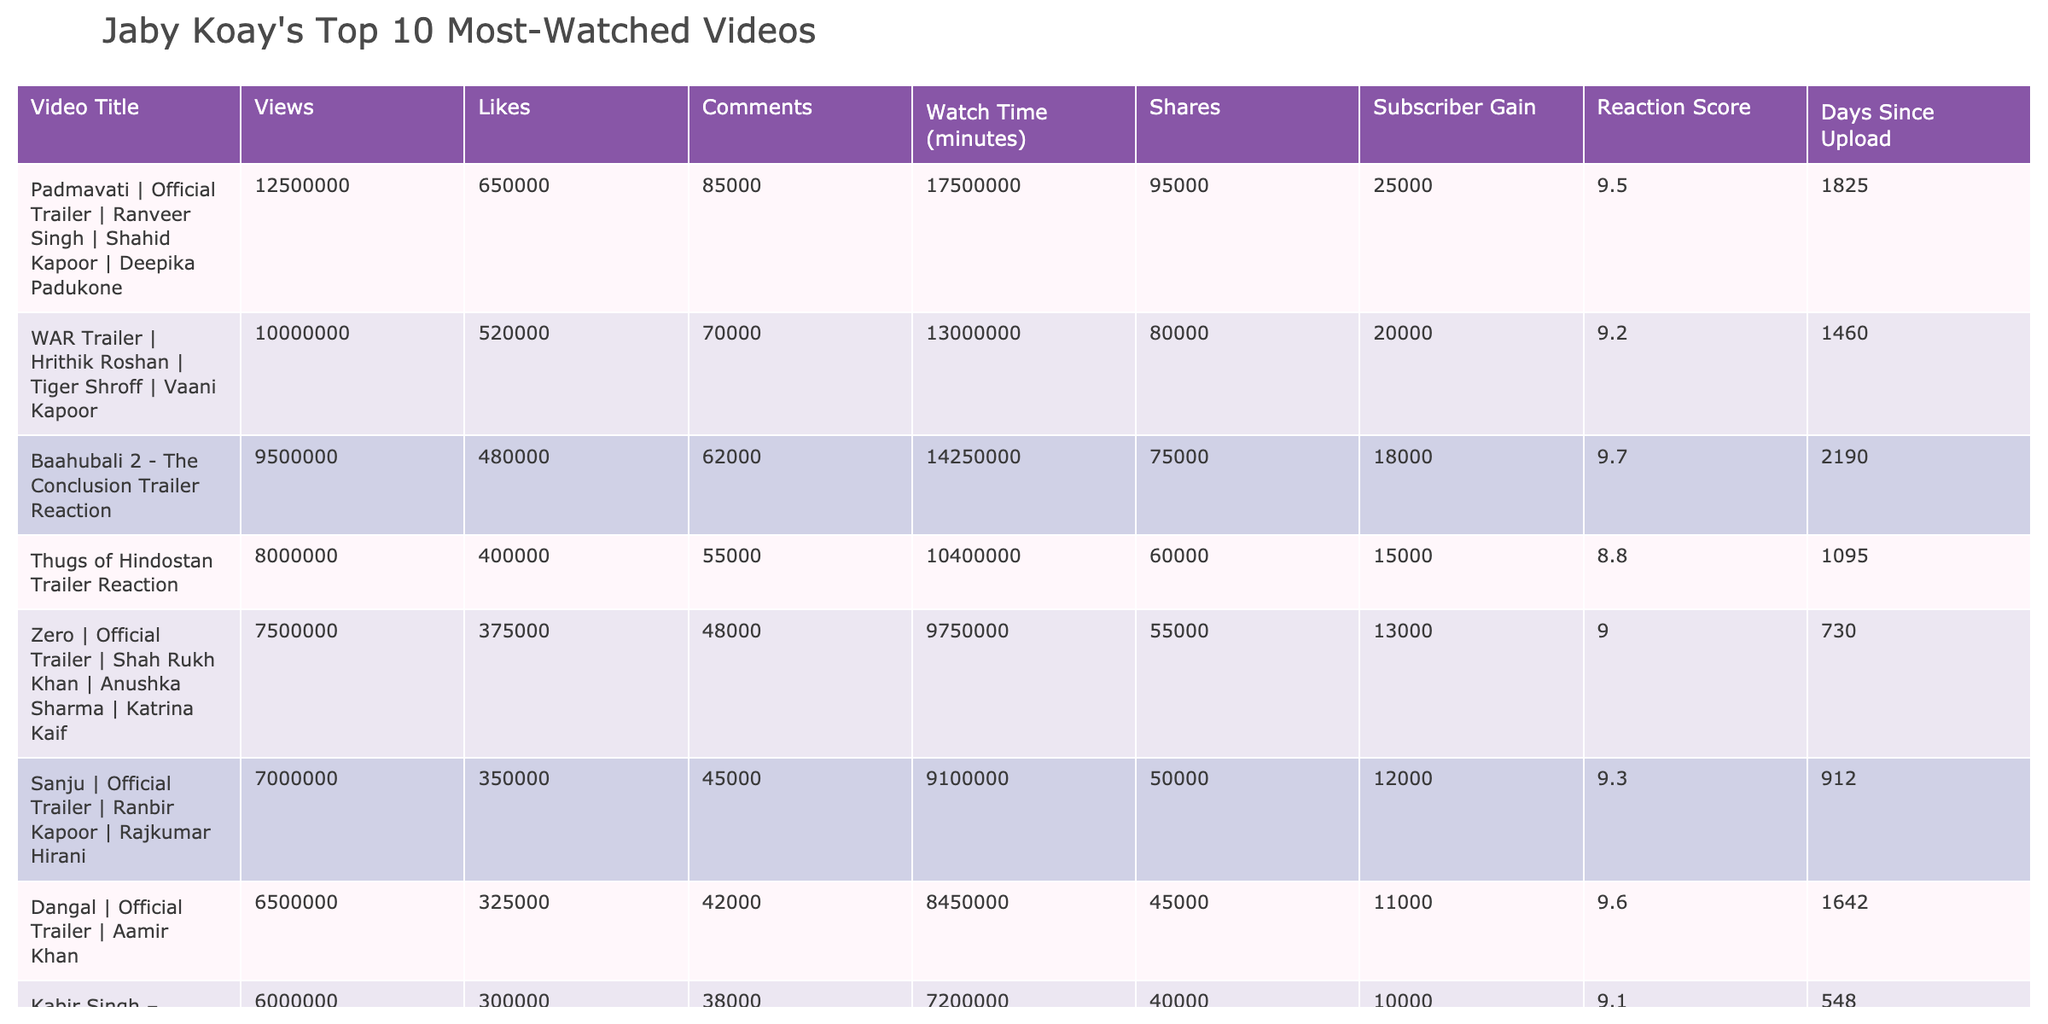What is the total number of views across all 10 videos? To find the total number of views, we add the views of each video: 12,500,000 + 10,000,000 + 9,500,000 + 8,000,000 + 7,500,000 + 7,000,000 + 6,500,000 + 6,000,000 + 5,500,000 + 5,000,000 = 77,500,000.
Answer: 77,500,000 What is the average watch time of the videos? The total watch time of all videos is 17,500,000 + 13,000,000 + 14,250,000 + 10,400,000 + 9,750,000 + 9,100,000 + 8,450,000 + 7,200,000 + 6,600,000 + 5,500,000 = 81,500,000. Dividing by 10 gives an average of 8,150,000 minutes.
Answer: 8,150,000 minutes Is the video "Thugs of Hindostan Trailer Reaction" among the top 5 most-watched videos? By examining the view counts, "Thugs of Hindostan" had 8,000,000 views, which is less than the top 5 view counts (12.5M, 10M, 9.5M, 8M, 7.5M), so it is not among the top 5.
Answer: No What is the difference in subscriber gain between the video with the highest views and the one with the lowest views? The video with the highest views is "Padmavati" with 25,000 subscribers gained, while the lowest, "Student Of The Year 2," gained 8,000. The difference is 25,000 - 8,000 = 17,000 subscribers.
Answer: 17,000 What is the average reaction score of the videos? The reaction scores are summed: 9.5 + 9.2 + 9.7 + 8.8 + 9.0 + 9.3 + 9.6 + 9.1 + 9.4 + 8.9 = 91.1, and then divided by 10 for an average of 9.11.
Answer: 9.11 Is there a correlation between likes and views in the top 10 videos? By analyzing the likes and views together, generally, a higher view count correlates with a higher like count evidenced through visual representation. This suggests a positive correlation exists.
Answer: Yes What is the overall subscriber gain from the videos? Summing the subscriber gains gives: 25,000 + 20,000 + 18,000 + 15,000 + 13,000 + 12,000 + 11,000 + 10,000 + 9,000 + 8,000 =  161,000 overall subscriber gain.
Answer: 161,000 Which video has the smallest number of comments? The comments were examined, and "Student Of The Year 2" has the least at 32,000 comments.
Answer: "Student Of The Year 2" 